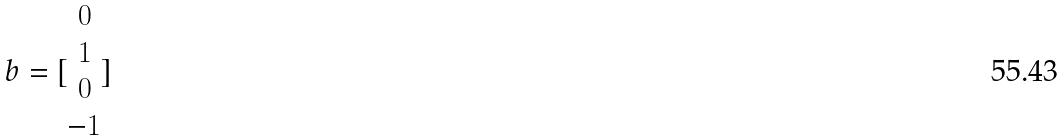Convert formula to latex. <formula><loc_0><loc_0><loc_500><loc_500>b = [ \begin{matrix} 0 \\ 1 \\ 0 \\ - 1 \end{matrix} ]</formula> 